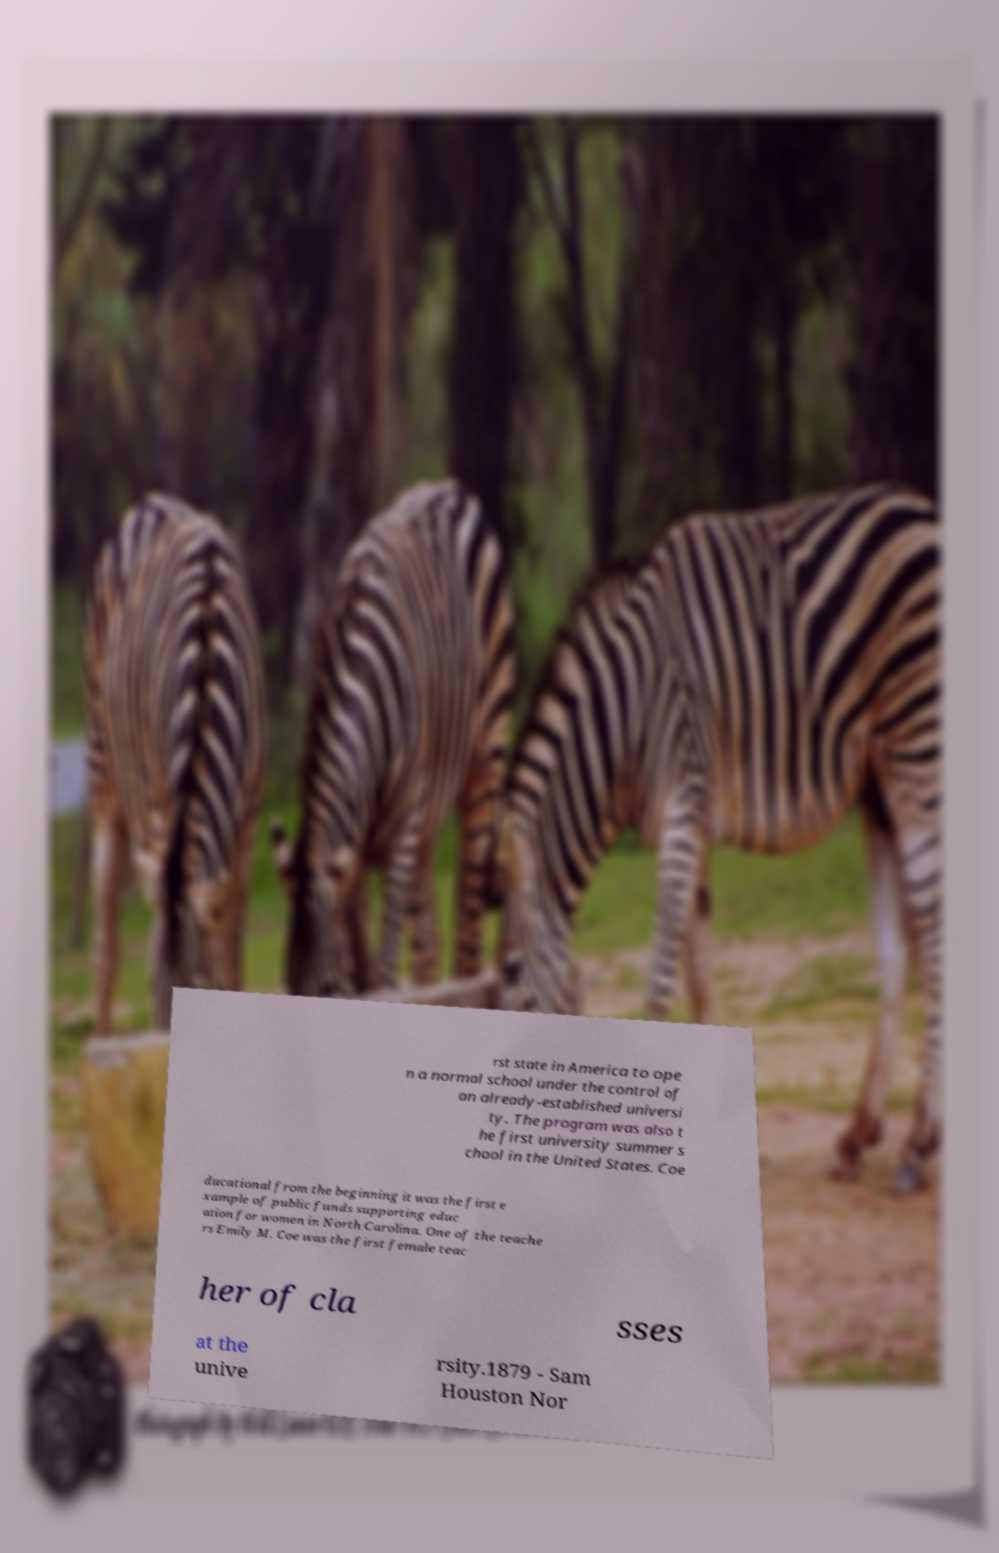What messages or text are displayed in this image? I need them in a readable, typed format. rst state in America to ope n a normal school under the control of an already-established universi ty. The program was also t he first university summer s chool in the United States. Coe ducational from the beginning it was the first e xample of public funds supporting educ ation for women in North Carolina. One of the teache rs Emily M. Coe was the first female teac her of cla sses at the unive rsity.1879 - Sam Houston Nor 